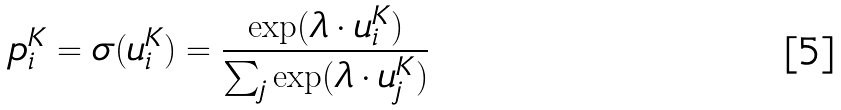<formula> <loc_0><loc_0><loc_500><loc_500>p ^ { K } _ { i } = \sigma ( u ^ { K } _ { i } ) = \frac { \exp ( \lambda \cdot u ^ { K } _ { i } ) } { \sum _ { j } \exp ( \lambda \cdot u ^ { K } _ { j } ) }</formula> 